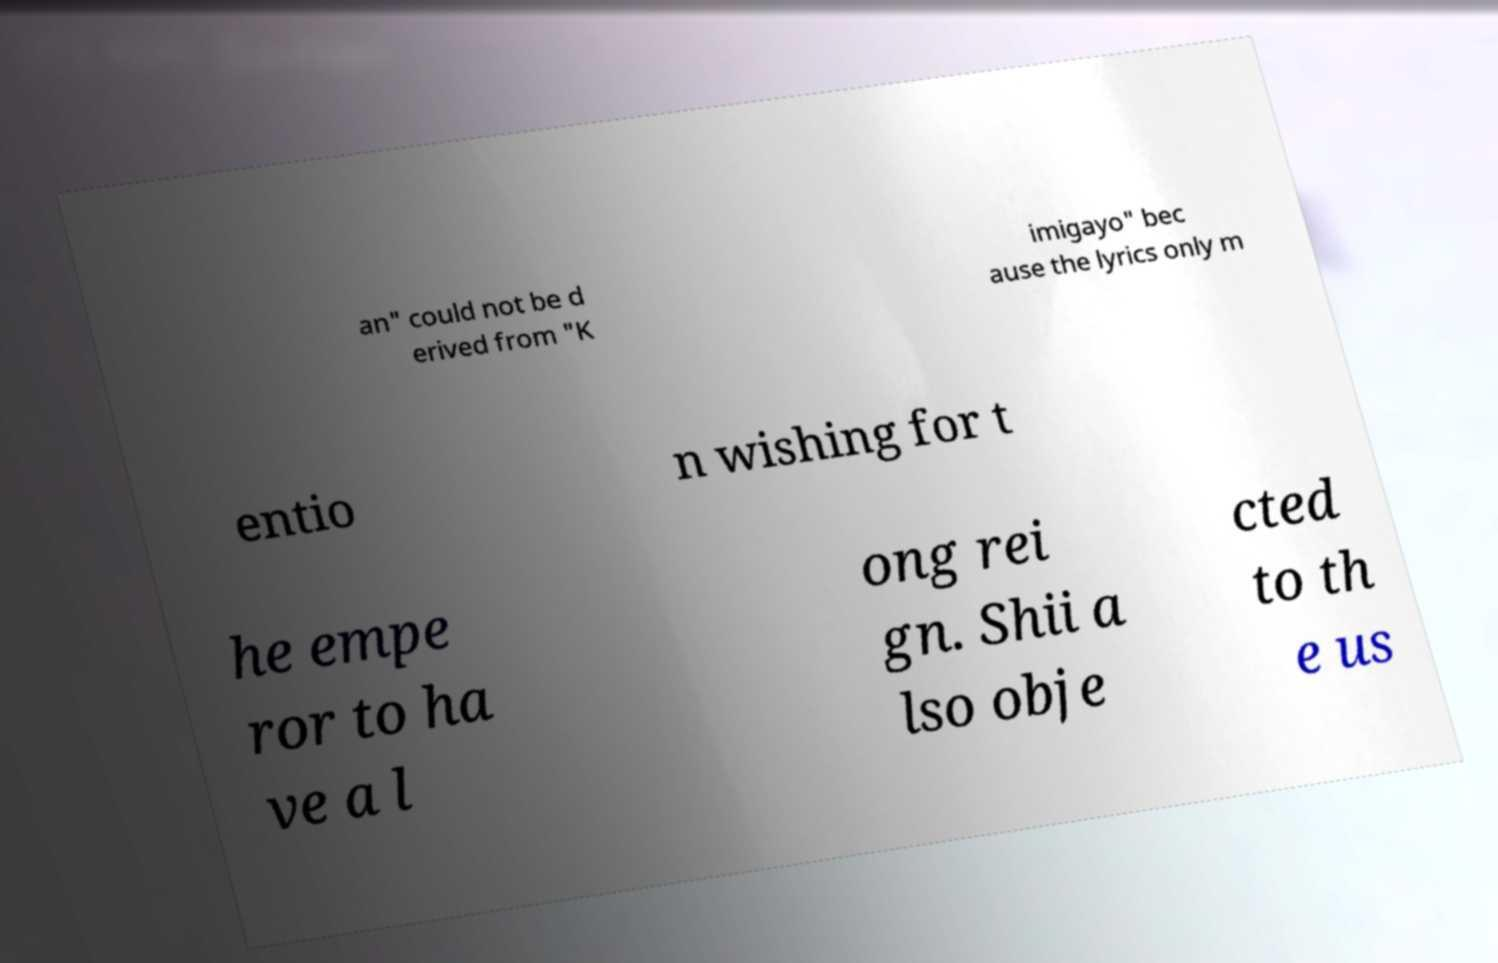Can you accurately transcribe the text from the provided image for me? an" could not be d erived from "K imigayo" bec ause the lyrics only m entio n wishing for t he empe ror to ha ve a l ong rei gn. Shii a lso obje cted to th e us 